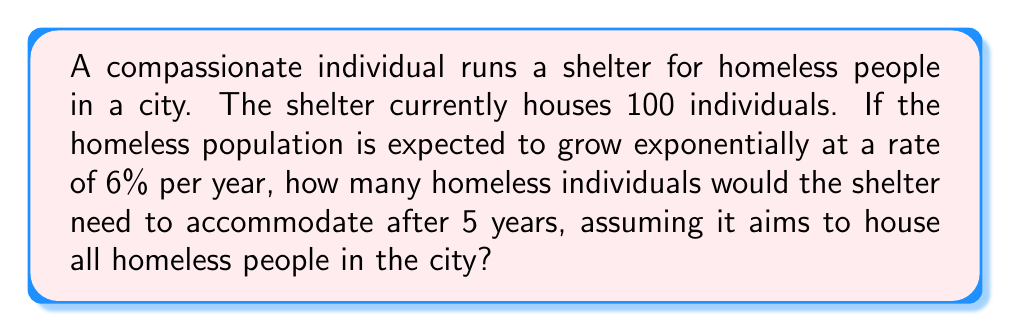Can you answer this question? Let's approach this problem step-by-step using an exponential growth model:

1) The exponential growth formula is:
   $A = P(1 + r)^t$
   Where:
   $A$ = Final amount
   $P$ = Initial amount
   $r$ = Growth rate (as a decimal)
   $t$ = Time period

2) We know:
   $P = 100$ (initial population)
   $r = 0.06$ (6% growth rate)
   $t = 5$ years

3) Let's plug these values into our formula:
   $A = 100(1 + 0.06)^5$

4) Simplify inside the parentheses:
   $A = 100(1.06)^5$

5) Calculate the exponent:
   $(1.06)^5 \approx 1.3382256$

6) Multiply:
   $A = 100 \times 1.3382256 \approx 133.82256$

7) Since we're dealing with people, we need to round up to the nearest whole number.

Therefore, after 5 years, the shelter would need to accommodate 134 homeless individuals.
Answer: 134 individuals 